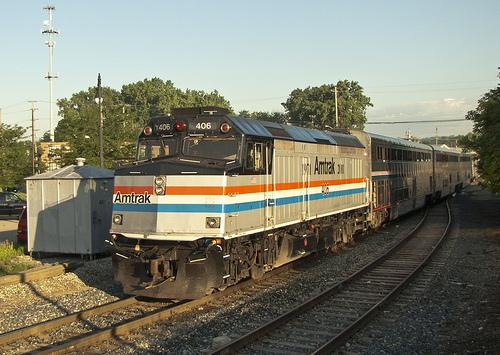List some additional elements outdoors, including nature and man-made structures in the image. There is a gray gravel scattered on the ground, a tall metal cell phone tower, and a black truck parked nearby. Mention three dominant colors and their corresponding objects in the image. Silver can be seen on the train and shed, green on the trees, and blue in the sky and a stripe on the train. What are the colors of the stripes on the train and the numbers printed on it? The stripes are orange, white, and blue, while the numbers are white. Identify the vehicle parked close to the train and a distinctive feature about that vehicle. A black truck is parked nearby, and it appears to have the back end visible. Describe the condition of the sky, trees, and train tracks in the image. The sky is clear blue with white clouds, the trees are leafy and green, and the train tracks are clear. Identify three distinct features on the image's train. The train has an orange and blue stripe, white number 406, and a round red light on its front. Mention some characteristics of the train's appearance, including color and design elements. The train is silver with orange, white, and blue stripes, a black logo, and red lights on the front. What type of building can be seen near the train, and what color is it? There is a small silver building, which appears to be a shed, located near the train. Tell us about the windows and the red lights on the train. There are two windows on the front of the train, with a red light on each corner and two red lights in the middle. Provide a brief description of the overall scene in the image. A silver train with orange, white, and blue stripes is parked on clear tracks by a green tree, silver shed, and a blue sky filled with white clouds. 